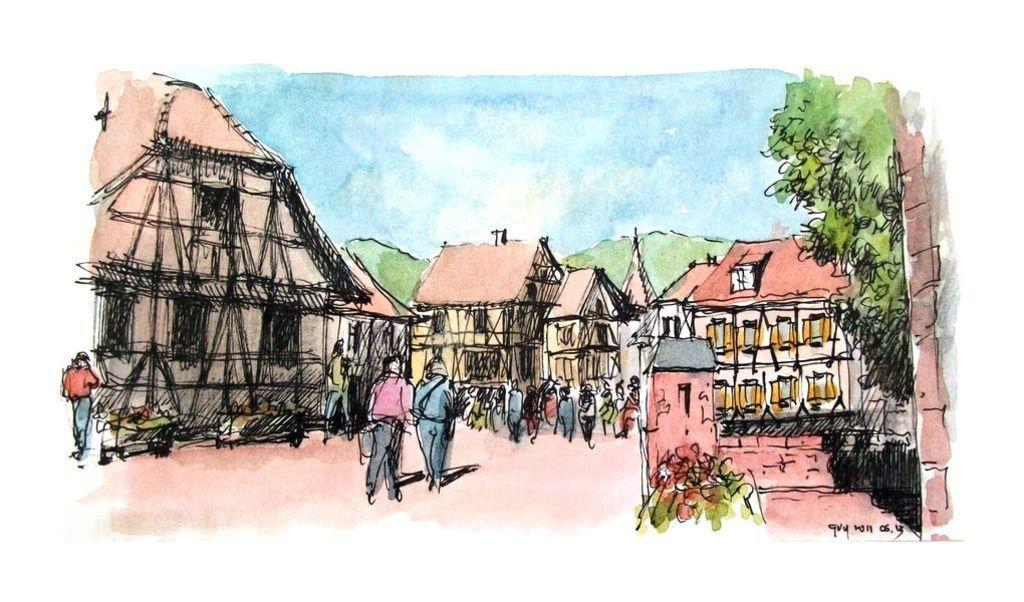Describe this image in one or two sentences. This is an animated image, in this image there are some houses and some people are walking and some of them are standing. In the background there are some trees. 